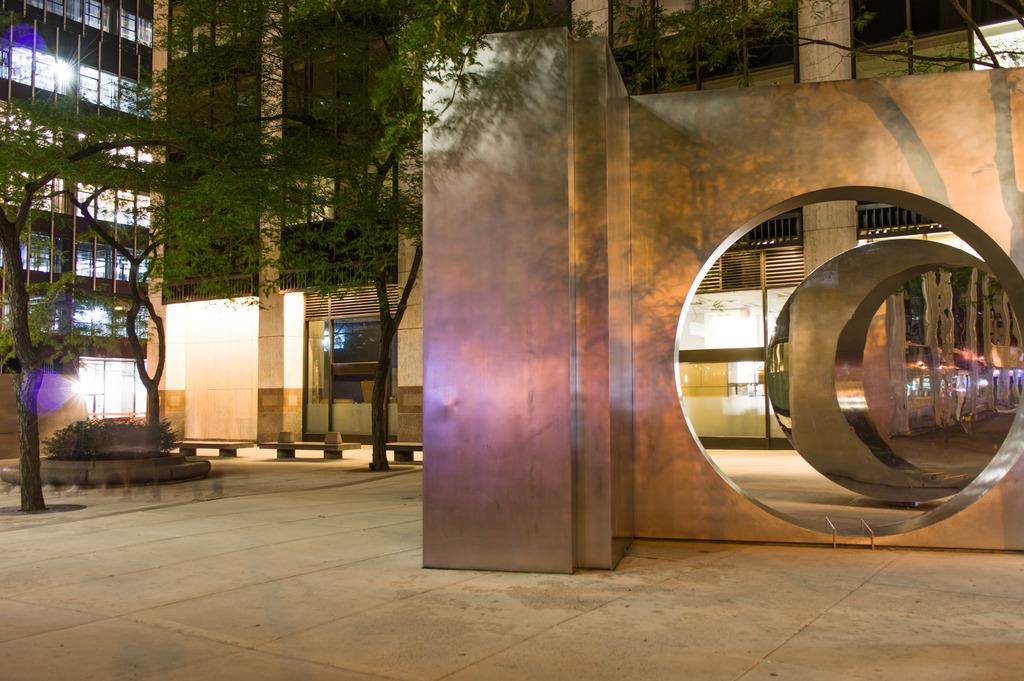What type of structure is visible in the image? There is an architecture in the image. What can be seen on the left side of the architecture? There are trees, plants, and benches on the left side of the architecture. What is located behind the trees in the image? There are buildings behind the trees. Can you tell me what word the owl is saying in the image? There is no owl present in the image, so it is not possible to determine what word the owl might be saying. 